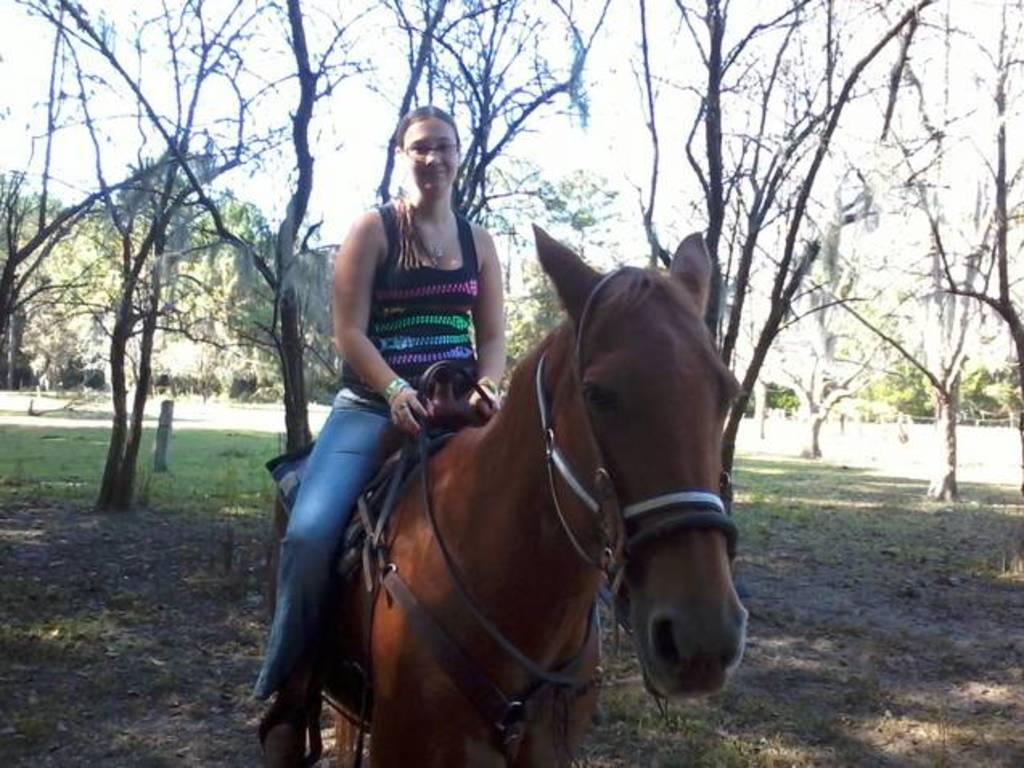Who is the main subject in the image? There is a woman in the image. What is the woman doing in the image? The woman is riding a horse. What can be seen in the background of the image? There are trees visible in the image. What type of celery is being used to power the horse in the image? There is no celery present in the image, and the horse is not being powered by any external source. 